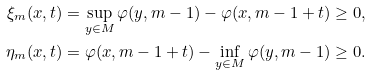<formula> <loc_0><loc_0><loc_500><loc_500>\xi _ { m } ( x , t ) & = \sup _ { y \in M } \varphi ( y , m - 1 ) - \varphi ( x , m - 1 + t ) \geq 0 , \\ \eta _ { m } ( x , t ) & = \varphi ( x , m - 1 + t ) - \inf _ { y \in M } \varphi ( y , m - 1 ) \geq 0 .</formula> 